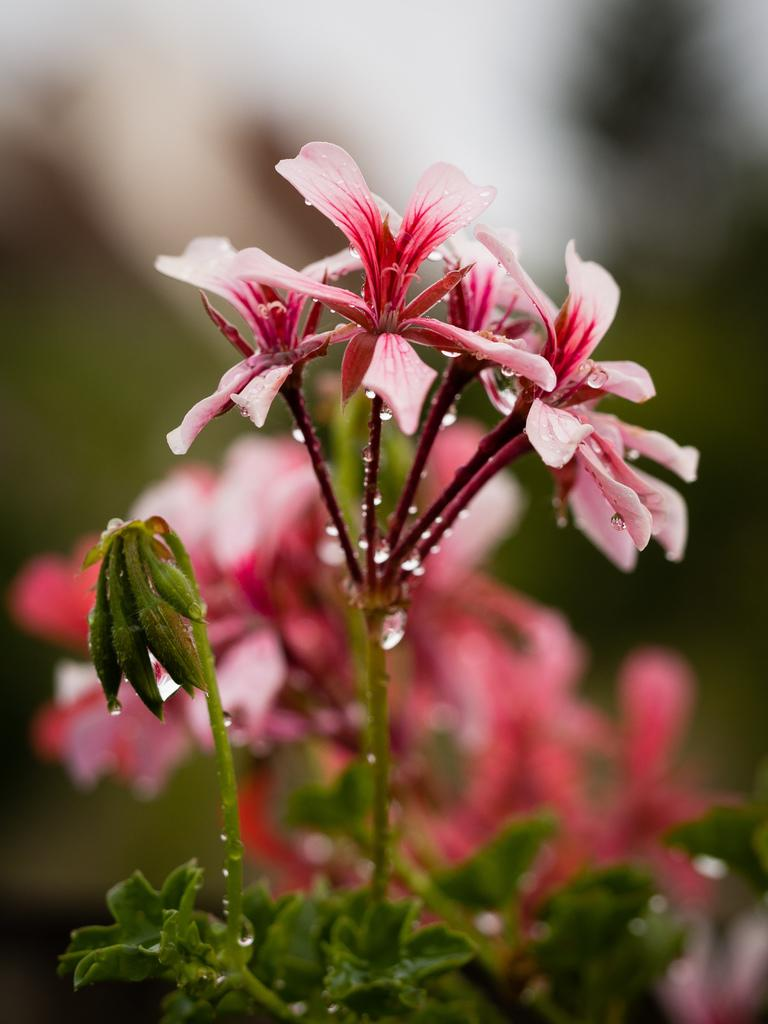What is the main subject of the image? The main subject of the image is a plant. What specific feature of the plant can be observed? The plant has flowers. Where is the plant and flowers located in the image? The plant and flowers are in the middle of the image. What type of bulb is visible on the face of the plant in the image? There is no bulb or face present on the plant in the image; it is a regular plant with flowers. 